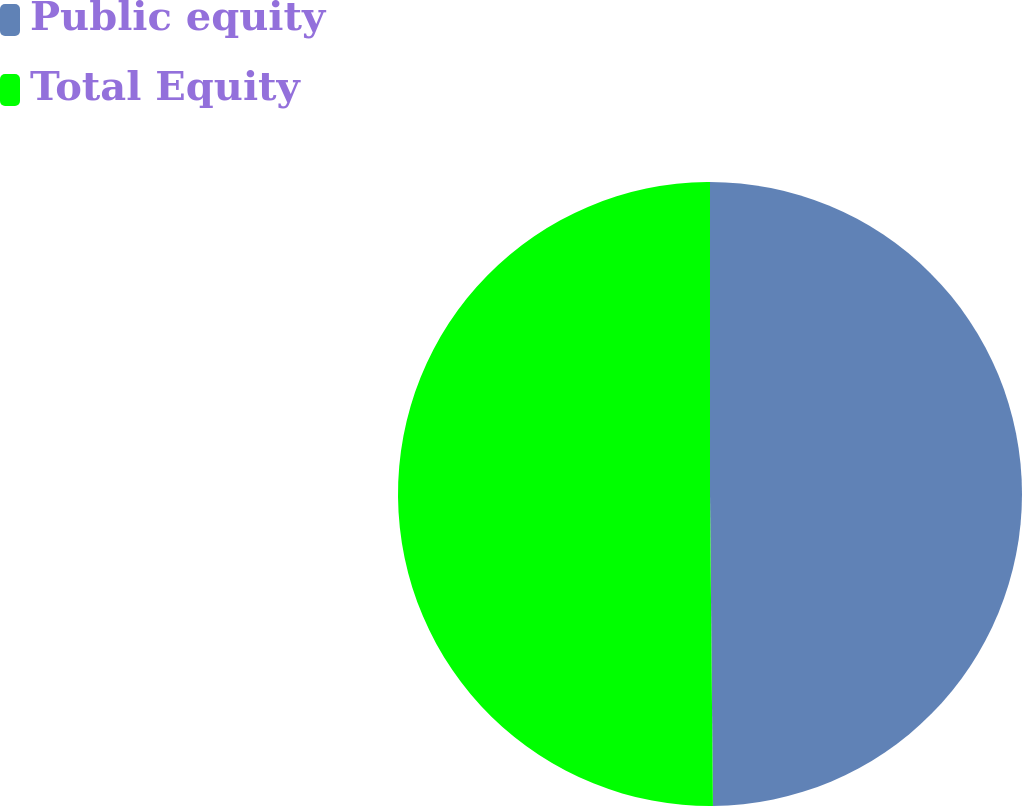Convert chart to OTSL. <chart><loc_0><loc_0><loc_500><loc_500><pie_chart><fcel>Public equity<fcel>Total Equity<nl><fcel>49.85%<fcel>50.15%<nl></chart> 